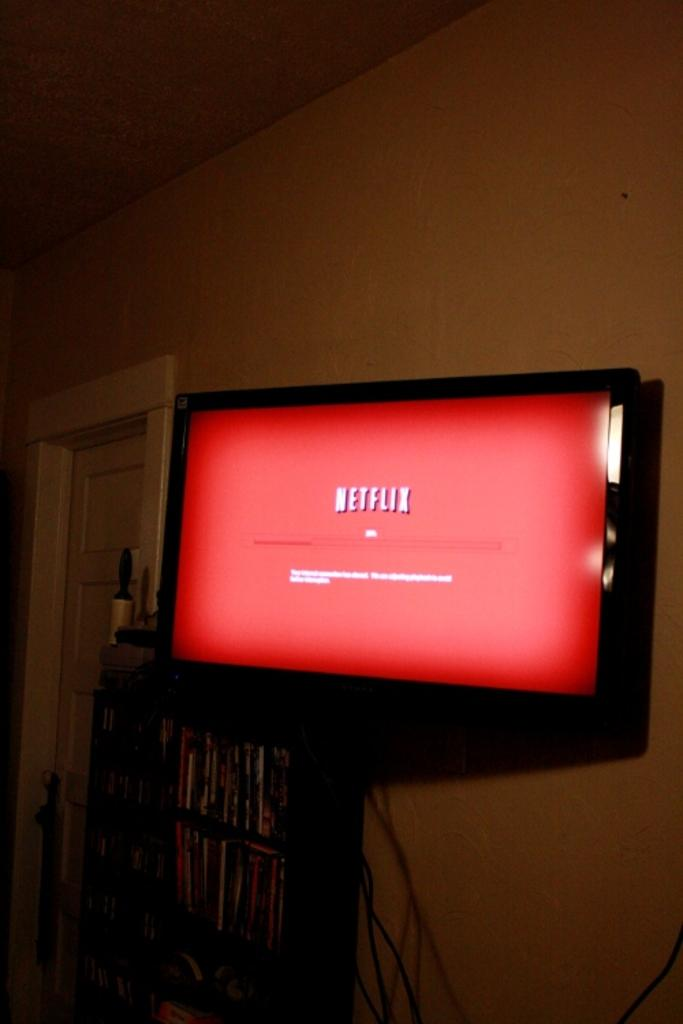<image>
Provide a brief description of the given image. A television showing a red "Netflix" screen is in the middle of an update. 